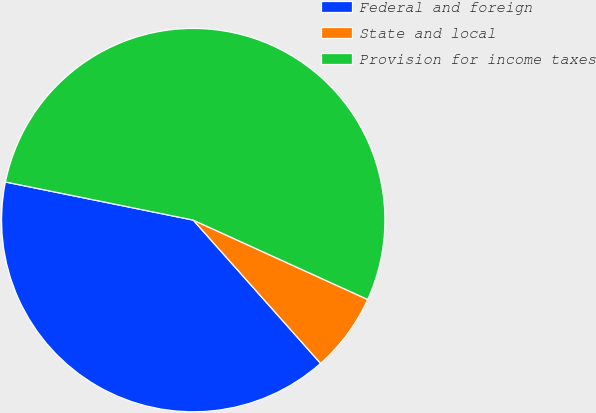Convert chart. <chart><loc_0><loc_0><loc_500><loc_500><pie_chart><fcel>Federal and foreign<fcel>State and local<fcel>Provision for income taxes<nl><fcel>39.75%<fcel>6.64%<fcel>53.61%<nl></chart> 